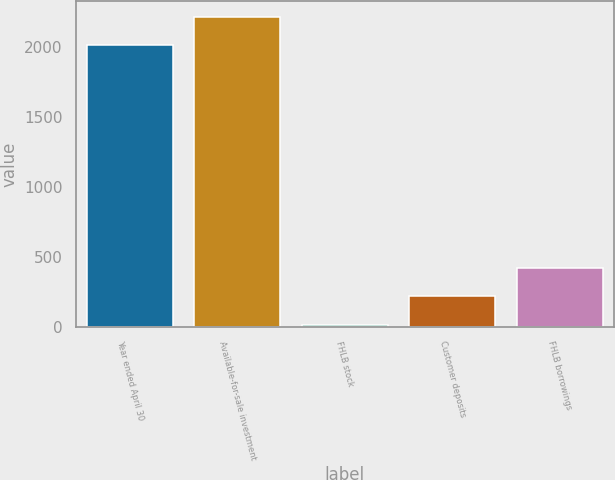Convert chart. <chart><loc_0><loc_0><loc_500><loc_500><bar_chart><fcel>Year ended April 30<fcel>Available-for-sale investment<fcel>FHLB stock<fcel>Customer deposits<fcel>FHLB borrowings<nl><fcel>2012<fcel>2213.2<fcel>15<fcel>216.2<fcel>417.4<nl></chart> 